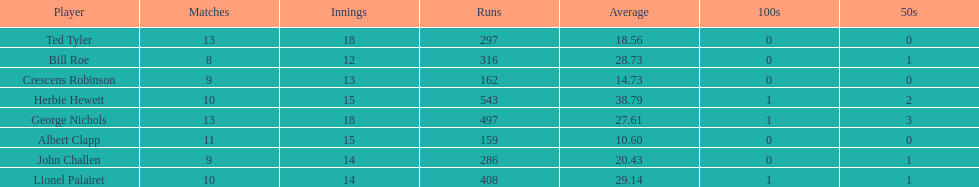What is the least about of runs anyone has? 159. 